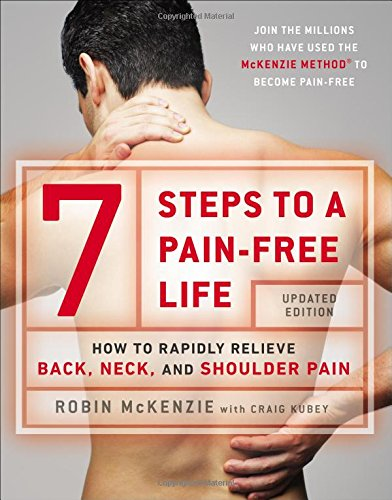Is this a fitness book? Yes, this book can be categorized under fitness, as it provides guided methods and exercises for readers to achieve better physical health and pain relief. 